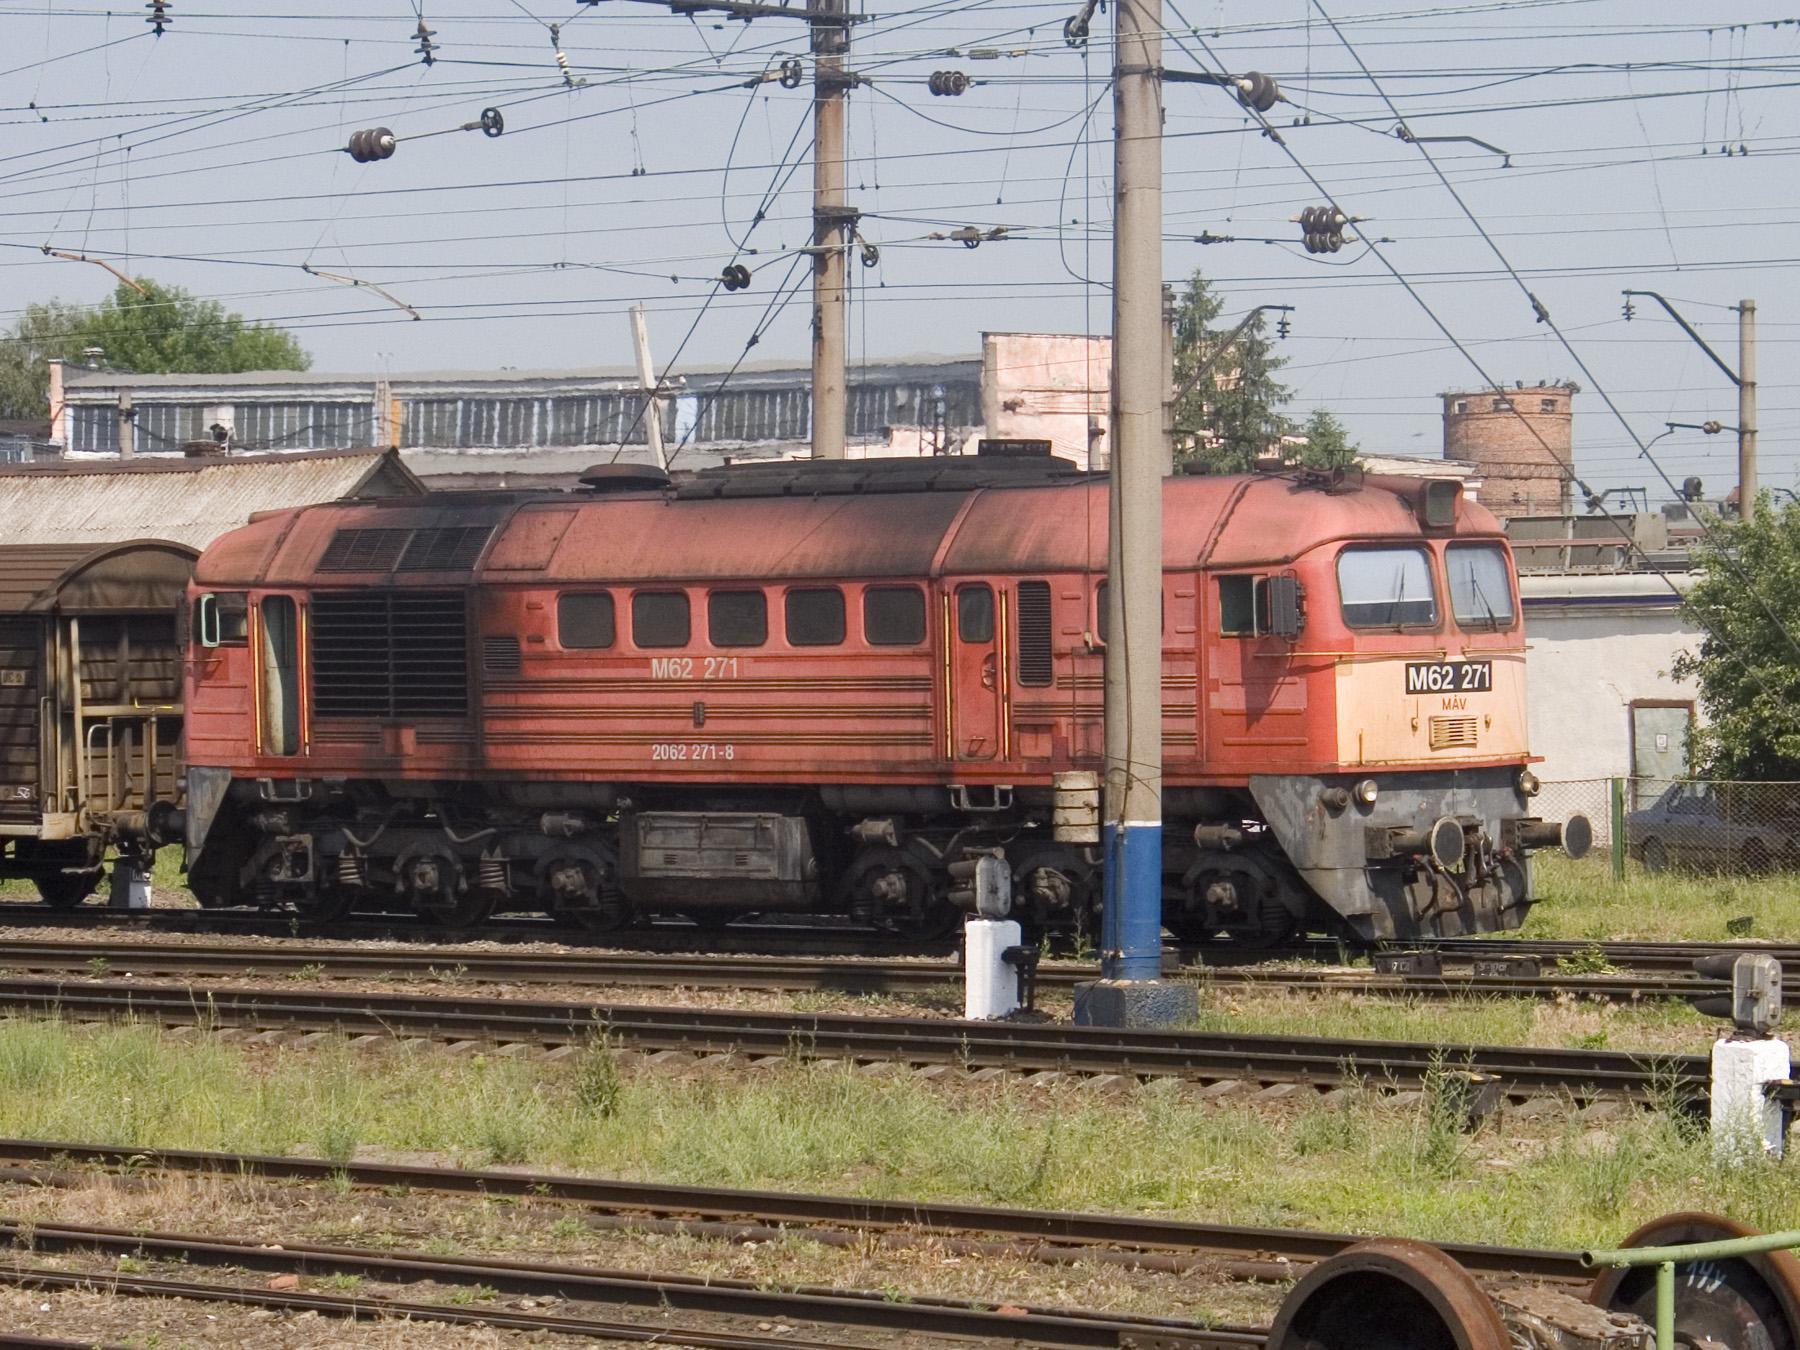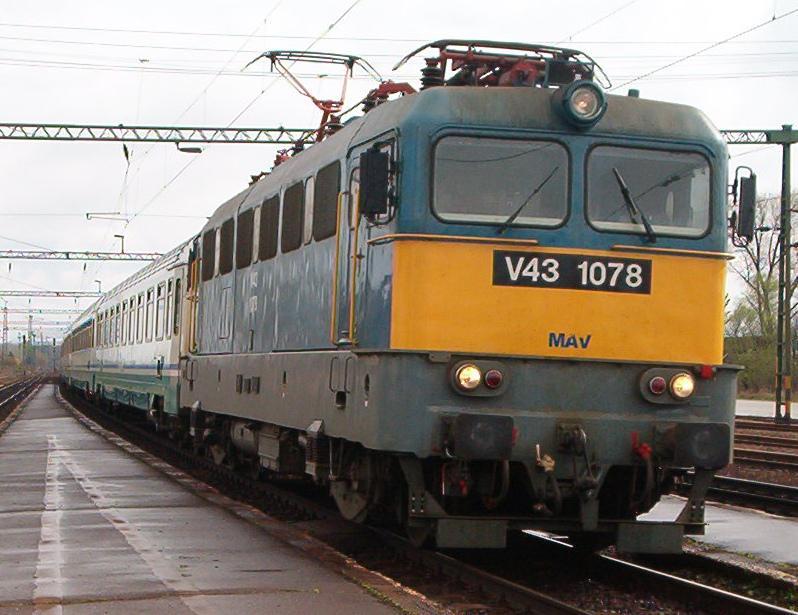The first image is the image on the left, the second image is the image on the right. Analyze the images presented: Is the assertion "The red train car is moving toward the right." valid? Answer yes or no. Yes. The first image is the image on the left, the second image is the image on the right. For the images shown, is this caption "An image shows a reddish-orange train facing rightward." true? Answer yes or no. Yes. 